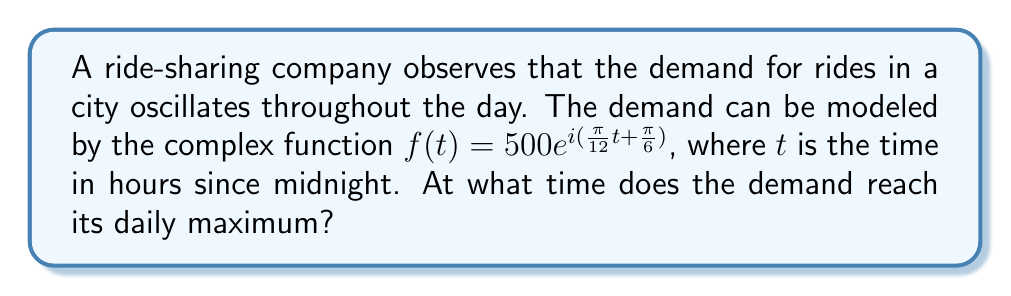What is the answer to this math problem? To solve this problem, we need to follow these steps:

1) The given function is in the form of a complex exponential: $f(t) = Ae^{i(\omega t + \phi)}$
   Where $A = 500$, $\omega = \frac{\pi}{12}$, and $\phi = \frac{\pi}{6}$

2) In this form, $A$ represents the amplitude, $\omega$ the angular frequency, and $\phi$ the phase shift.

3) The real part of this function represents the actual demand:
   $\text{Re}(f(t)) = 500\cos(\frac{\pi}{12}t + \frac{\pi}{6})$

4) The demand reaches its maximum when the cosine function equals 1, which occurs when its argument is a multiple of $2\pi$:

   $$\frac{\pi}{12}t + \frac{\pi}{6} = 2\pi n$$
   Where $n$ is an integer.

5) Solving for $t$:

   $$\frac{\pi}{12}t = 2\pi n - \frac{\pi}{6}$$
   $$t = 24n - 2$$

6) The first positive solution (n = 1) gives us:
   $t = 22$

Therefore, the demand reaches its daily maximum at 22:00 or 10:00 PM.
Answer: 22:00 (10:00 PM) 